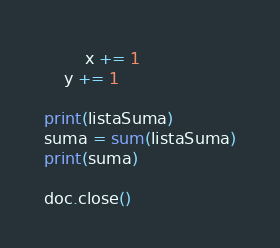Convert code to text. <code><loc_0><loc_0><loc_500><loc_500><_Python_>		x += 1
	y += 1

print(listaSuma)
suma = sum(listaSuma)
print(suma)

doc.close()</code> 